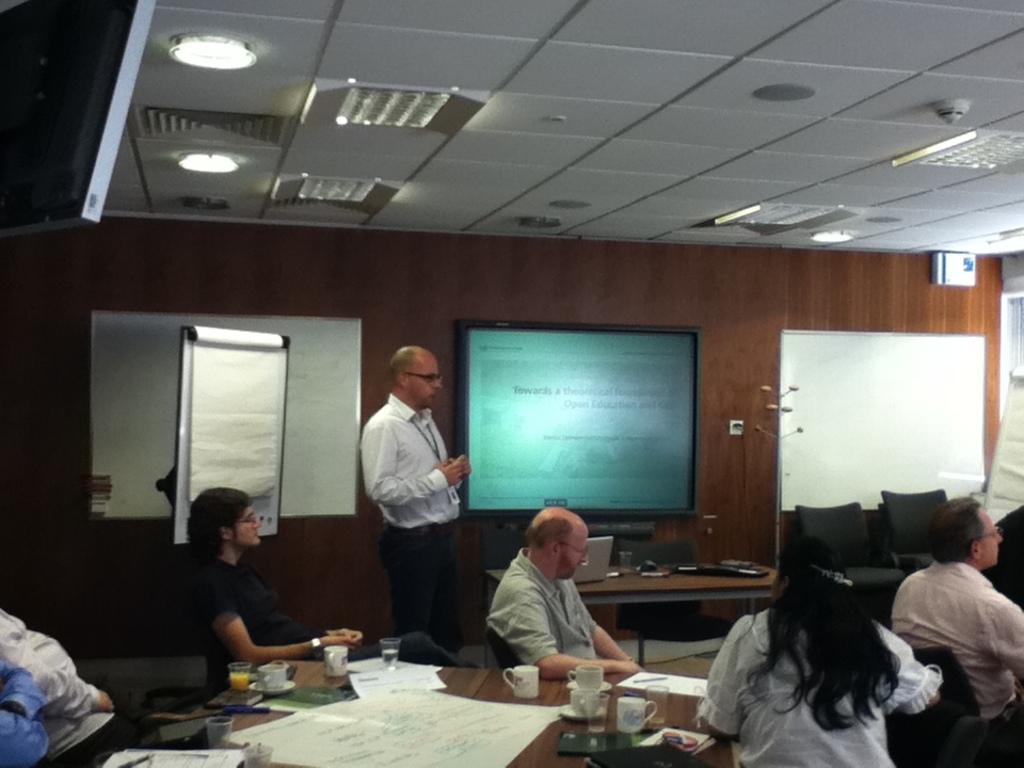How would you summarize this image in a sentence or two? In the picture there are tables and chairs present, there are people sitting on the chairs, one person is standing, on the table there are many papers present, there are cups and glasses present, there is a laptop present, there is a wall, on the wall there are two whiteboards and one board with the screen, there are lights present on the roof. 